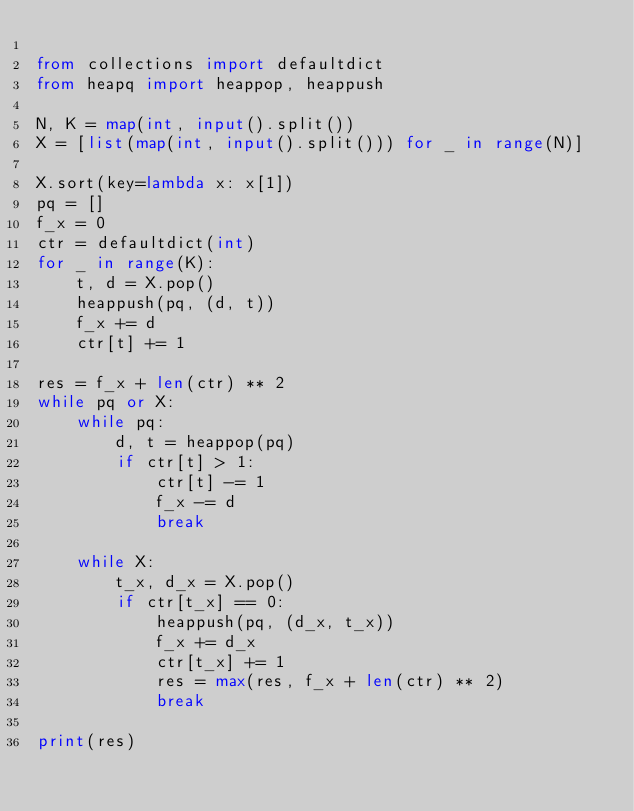<code> <loc_0><loc_0><loc_500><loc_500><_Python_>
from collections import defaultdict
from heapq import heappop, heappush

N, K = map(int, input().split())
X = [list(map(int, input().split())) for _ in range(N)]

X.sort(key=lambda x: x[1])
pq = []
f_x = 0
ctr = defaultdict(int)
for _ in range(K):
    t, d = X.pop()
    heappush(pq, (d, t))
    f_x += d
    ctr[t] += 1

res = f_x + len(ctr) ** 2
while pq or X:
    while pq:
        d, t = heappop(pq)
        if ctr[t] > 1:
            ctr[t] -= 1
            f_x -= d
            break

    while X:
        t_x, d_x = X.pop()
        if ctr[t_x] == 0:
            heappush(pq, (d_x, t_x))
            f_x += d_x
            ctr[t_x] += 1
            res = max(res, f_x + len(ctr) ** 2)
            break

print(res)
</code> 